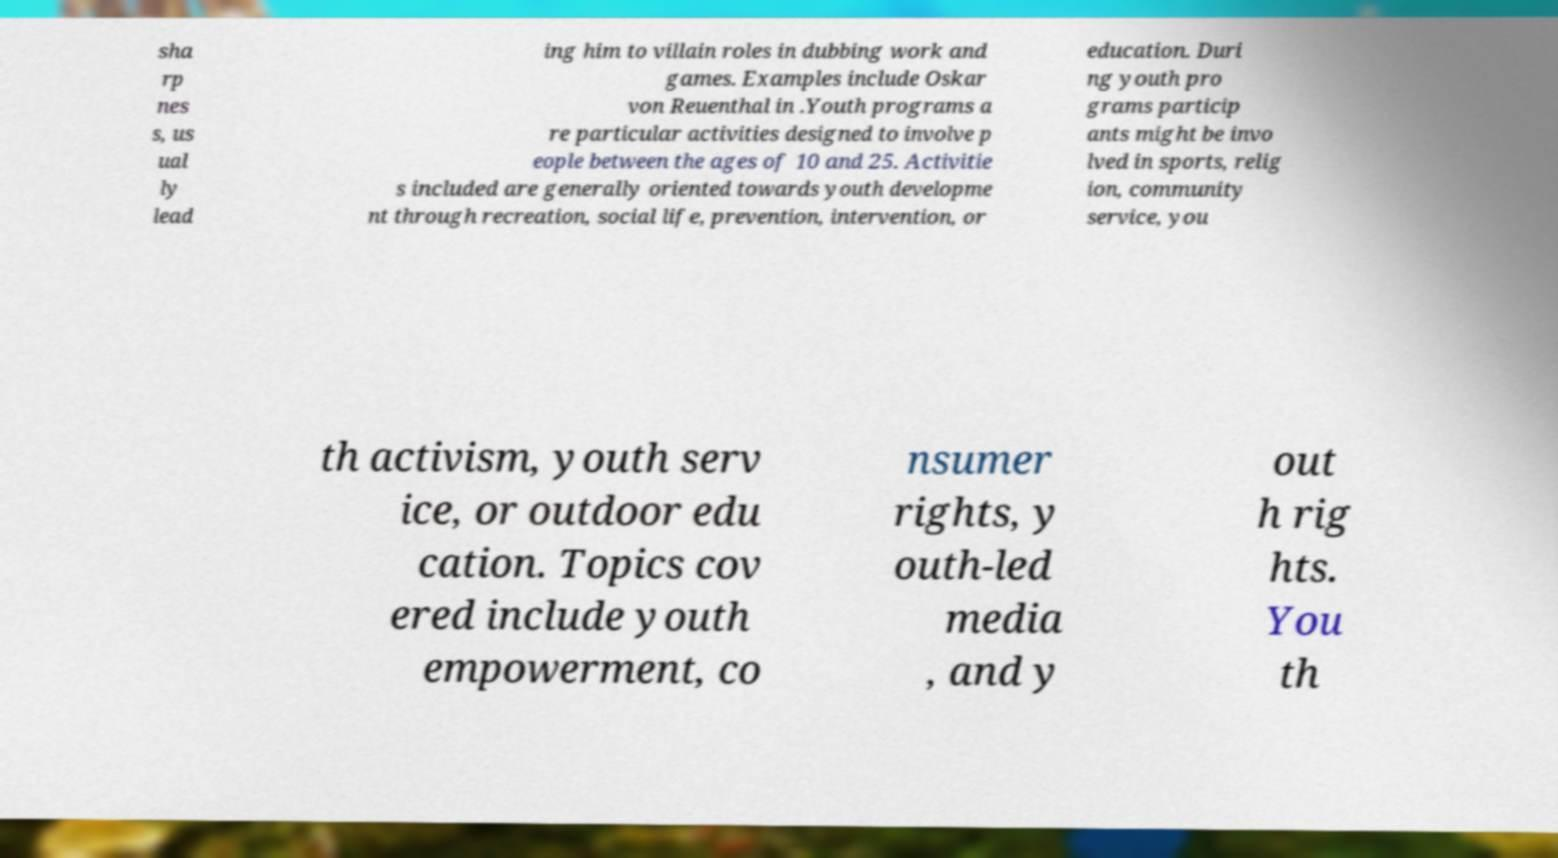Can you read and provide the text displayed in the image?This photo seems to have some interesting text. Can you extract and type it out for me? sha rp nes s, us ual ly lead ing him to villain roles in dubbing work and games. Examples include Oskar von Reuenthal in .Youth programs a re particular activities designed to involve p eople between the ages of 10 and 25. Activitie s included are generally oriented towards youth developme nt through recreation, social life, prevention, intervention, or education. Duri ng youth pro grams particip ants might be invo lved in sports, relig ion, community service, you th activism, youth serv ice, or outdoor edu cation. Topics cov ered include youth empowerment, co nsumer rights, y outh-led media , and y out h rig hts. You th 